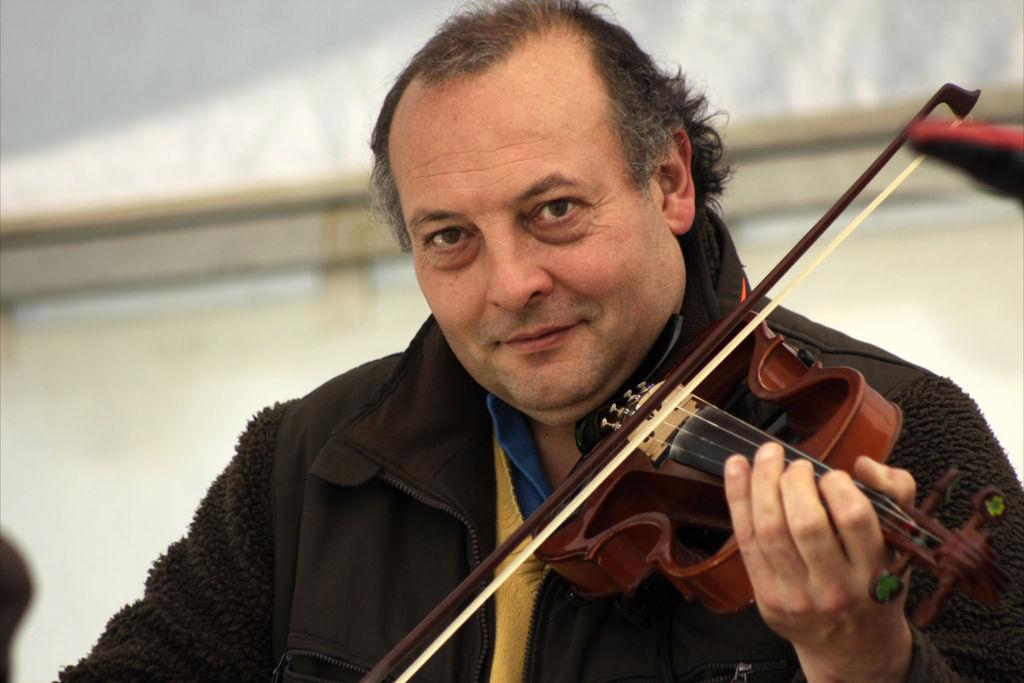What is the man in the image doing? The man is playing a violin. What is the man wearing while playing the violin? The man is wearing a jacket. What type of honey is the man using to play the violin in the image? There is no honey present in the image, and the man is not using any to play the violin. 